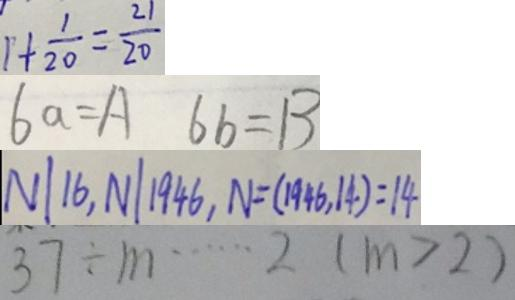Convert formula to latex. <formula><loc_0><loc_0><loc_500><loc_500>1 + \frac { 1 } { 2 0 } = \frac { 2 1 } { 2 0 } 
 6 a = A 6 b = B 
 N \vert 1 6 , N \vert 1 9 4 6 , N = ( 1 9 4 6 , 1 4 ) = 1 4 
 3 7 \div m \cdots 2 ( m > 2 )</formula> 